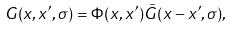<formula> <loc_0><loc_0><loc_500><loc_500>G ( x , x ^ { \prime } , \sigma ) = \Phi ( x , x ^ { \prime } ) \tilde { G } ( x - x ^ { \prime } , \sigma ) ,</formula> 